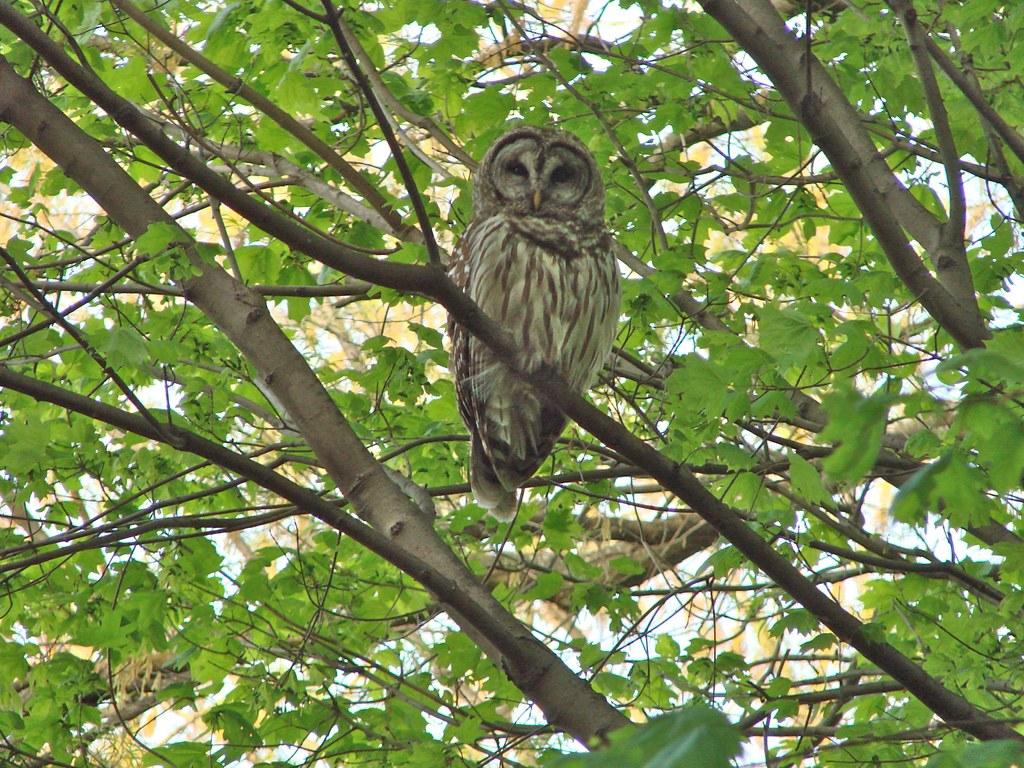What type of bird is in the image? There is an owl bird in the image. Where is the owl bird located? The owl bird is on a branch of a tree. What else can be seen in the image besides the owl bird? There are branches and green leaves visible in the image. What type of paste is being used to hold the button on the tree in the image? There is no paste or button present in the image; it features an owl bird on a branch of a tree with green leaves. 